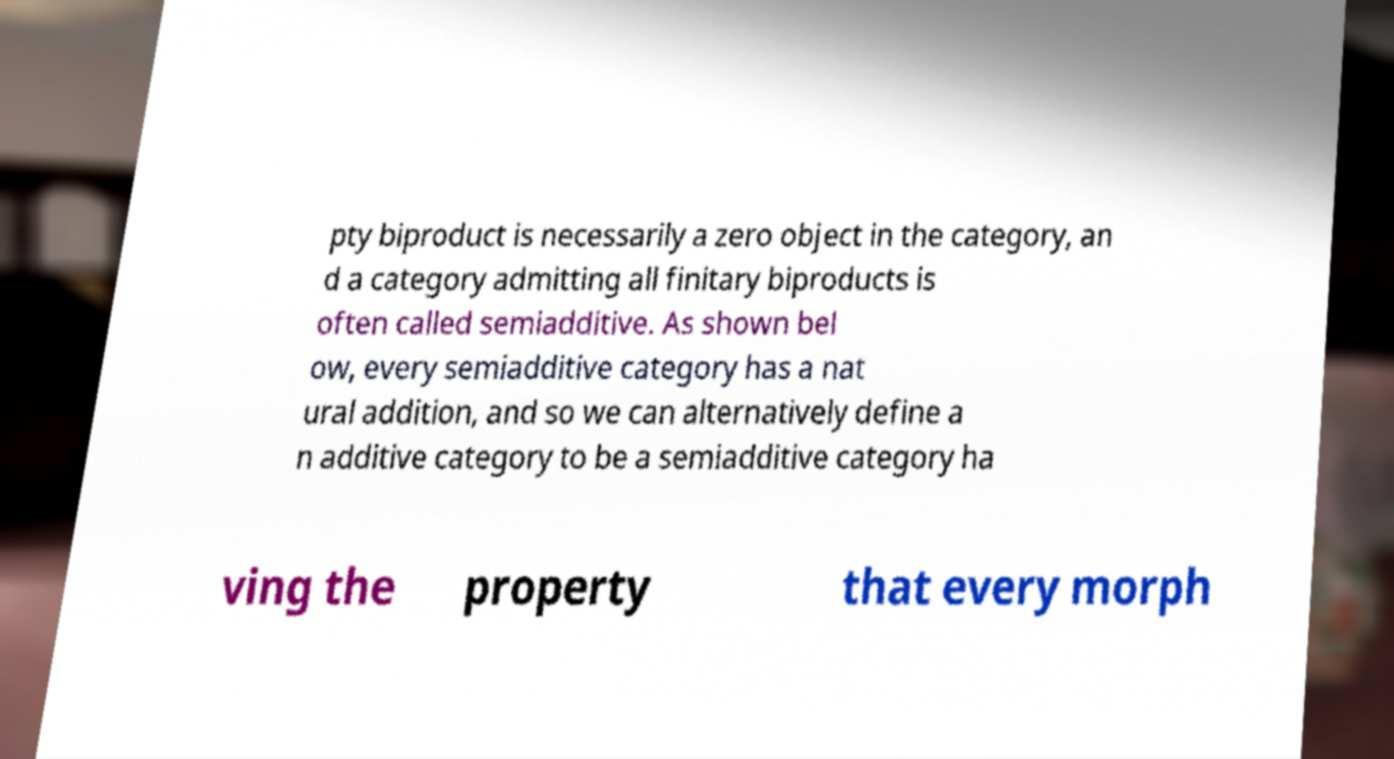Can you read and provide the text displayed in the image?This photo seems to have some interesting text. Can you extract and type it out for me? pty biproduct is necessarily a zero object in the category, an d a category admitting all finitary biproducts is often called semiadditive. As shown bel ow, every semiadditive category has a nat ural addition, and so we can alternatively define a n additive category to be a semiadditive category ha ving the property that every morph 